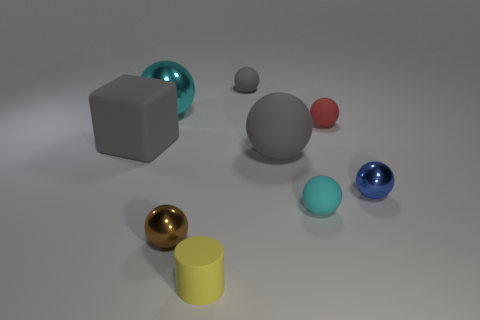Subtract all cyan balls. How many balls are left? 5 Subtract all tiny gray rubber spheres. How many spheres are left? 6 Subtract all yellow spheres. Subtract all blue cubes. How many spheres are left? 7 Add 1 blue metal balls. How many objects exist? 10 Subtract all balls. How many objects are left? 2 Add 8 cyan shiny balls. How many cyan shiny balls are left? 9 Add 8 purple rubber balls. How many purple rubber balls exist? 8 Subtract 0 brown cylinders. How many objects are left? 9 Subtract all tiny matte balls. Subtract all cyan things. How many objects are left? 4 